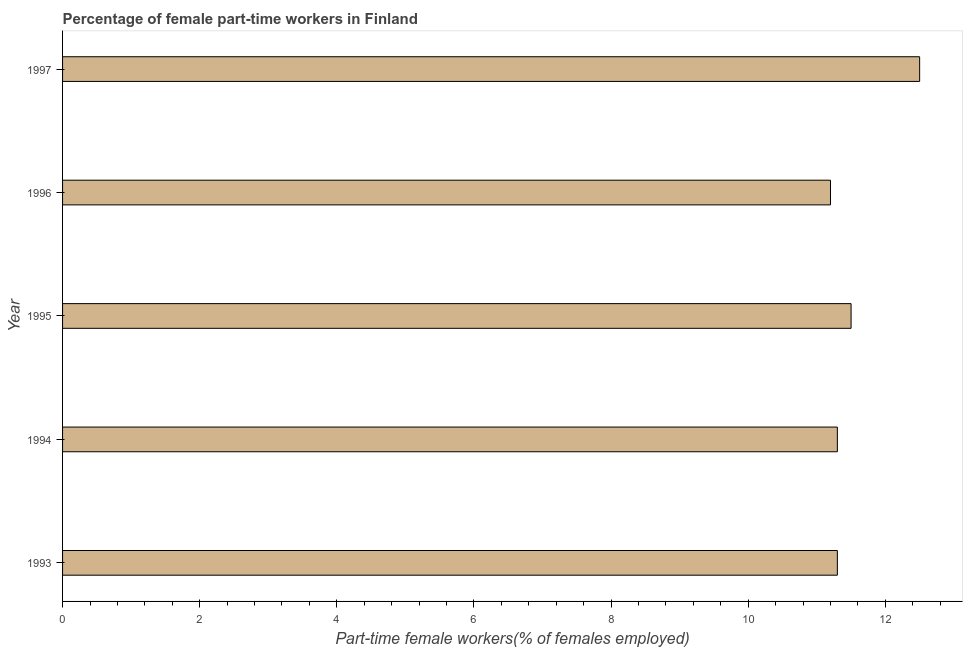Does the graph contain any zero values?
Keep it short and to the point. No. Does the graph contain grids?
Keep it short and to the point. No. What is the title of the graph?
Offer a very short reply. Percentage of female part-time workers in Finland. What is the label or title of the X-axis?
Make the answer very short. Part-time female workers(% of females employed). What is the label or title of the Y-axis?
Provide a succinct answer. Year. What is the percentage of part-time female workers in 1993?
Make the answer very short. 11.3. Across all years, what is the minimum percentage of part-time female workers?
Your answer should be compact. 11.2. In which year was the percentage of part-time female workers maximum?
Give a very brief answer. 1997. What is the sum of the percentage of part-time female workers?
Provide a succinct answer. 57.8. What is the average percentage of part-time female workers per year?
Your answer should be very brief. 11.56. What is the median percentage of part-time female workers?
Give a very brief answer. 11.3. In how many years, is the percentage of part-time female workers greater than 10.8 %?
Provide a short and direct response. 5. Do a majority of the years between 1997 and 1996 (inclusive) have percentage of part-time female workers greater than 7.2 %?
Your answer should be compact. No. What is the ratio of the percentage of part-time female workers in 1994 to that in 1997?
Keep it short and to the point. 0.9. Is the percentage of part-time female workers in 1995 less than that in 1997?
Offer a very short reply. Yes. Is the difference between the percentage of part-time female workers in 1995 and 1997 greater than the difference between any two years?
Keep it short and to the point. No. What is the difference between the highest and the second highest percentage of part-time female workers?
Provide a short and direct response. 1. Is the sum of the percentage of part-time female workers in 1993 and 1997 greater than the maximum percentage of part-time female workers across all years?
Offer a terse response. Yes. What is the difference between the highest and the lowest percentage of part-time female workers?
Keep it short and to the point. 1.3. In how many years, is the percentage of part-time female workers greater than the average percentage of part-time female workers taken over all years?
Make the answer very short. 1. How many years are there in the graph?
Make the answer very short. 5. What is the Part-time female workers(% of females employed) of 1993?
Your answer should be very brief. 11.3. What is the Part-time female workers(% of females employed) of 1994?
Offer a terse response. 11.3. What is the Part-time female workers(% of females employed) of 1995?
Your response must be concise. 11.5. What is the Part-time female workers(% of females employed) of 1996?
Your answer should be compact. 11.2. What is the Part-time female workers(% of females employed) in 1997?
Your answer should be compact. 12.5. What is the difference between the Part-time female workers(% of females employed) in 1993 and 1996?
Provide a succinct answer. 0.1. What is the difference between the Part-time female workers(% of females employed) in 1994 and 1996?
Make the answer very short. 0.1. What is the difference between the Part-time female workers(% of females employed) in 1994 and 1997?
Ensure brevity in your answer.  -1.2. What is the difference between the Part-time female workers(% of females employed) in 1995 and 1996?
Offer a terse response. 0.3. What is the ratio of the Part-time female workers(% of females employed) in 1993 to that in 1994?
Your answer should be very brief. 1. What is the ratio of the Part-time female workers(% of females employed) in 1993 to that in 1997?
Your response must be concise. 0.9. What is the ratio of the Part-time female workers(% of females employed) in 1994 to that in 1995?
Give a very brief answer. 0.98. What is the ratio of the Part-time female workers(% of females employed) in 1994 to that in 1996?
Make the answer very short. 1.01. What is the ratio of the Part-time female workers(% of females employed) in 1994 to that in 1997?
Offer a very short reply. 0.9. What is the ratio of the Part-time female workers(% of females employed) in 1996 to that in 1997?
Provide a short and direct response. 0.9. 